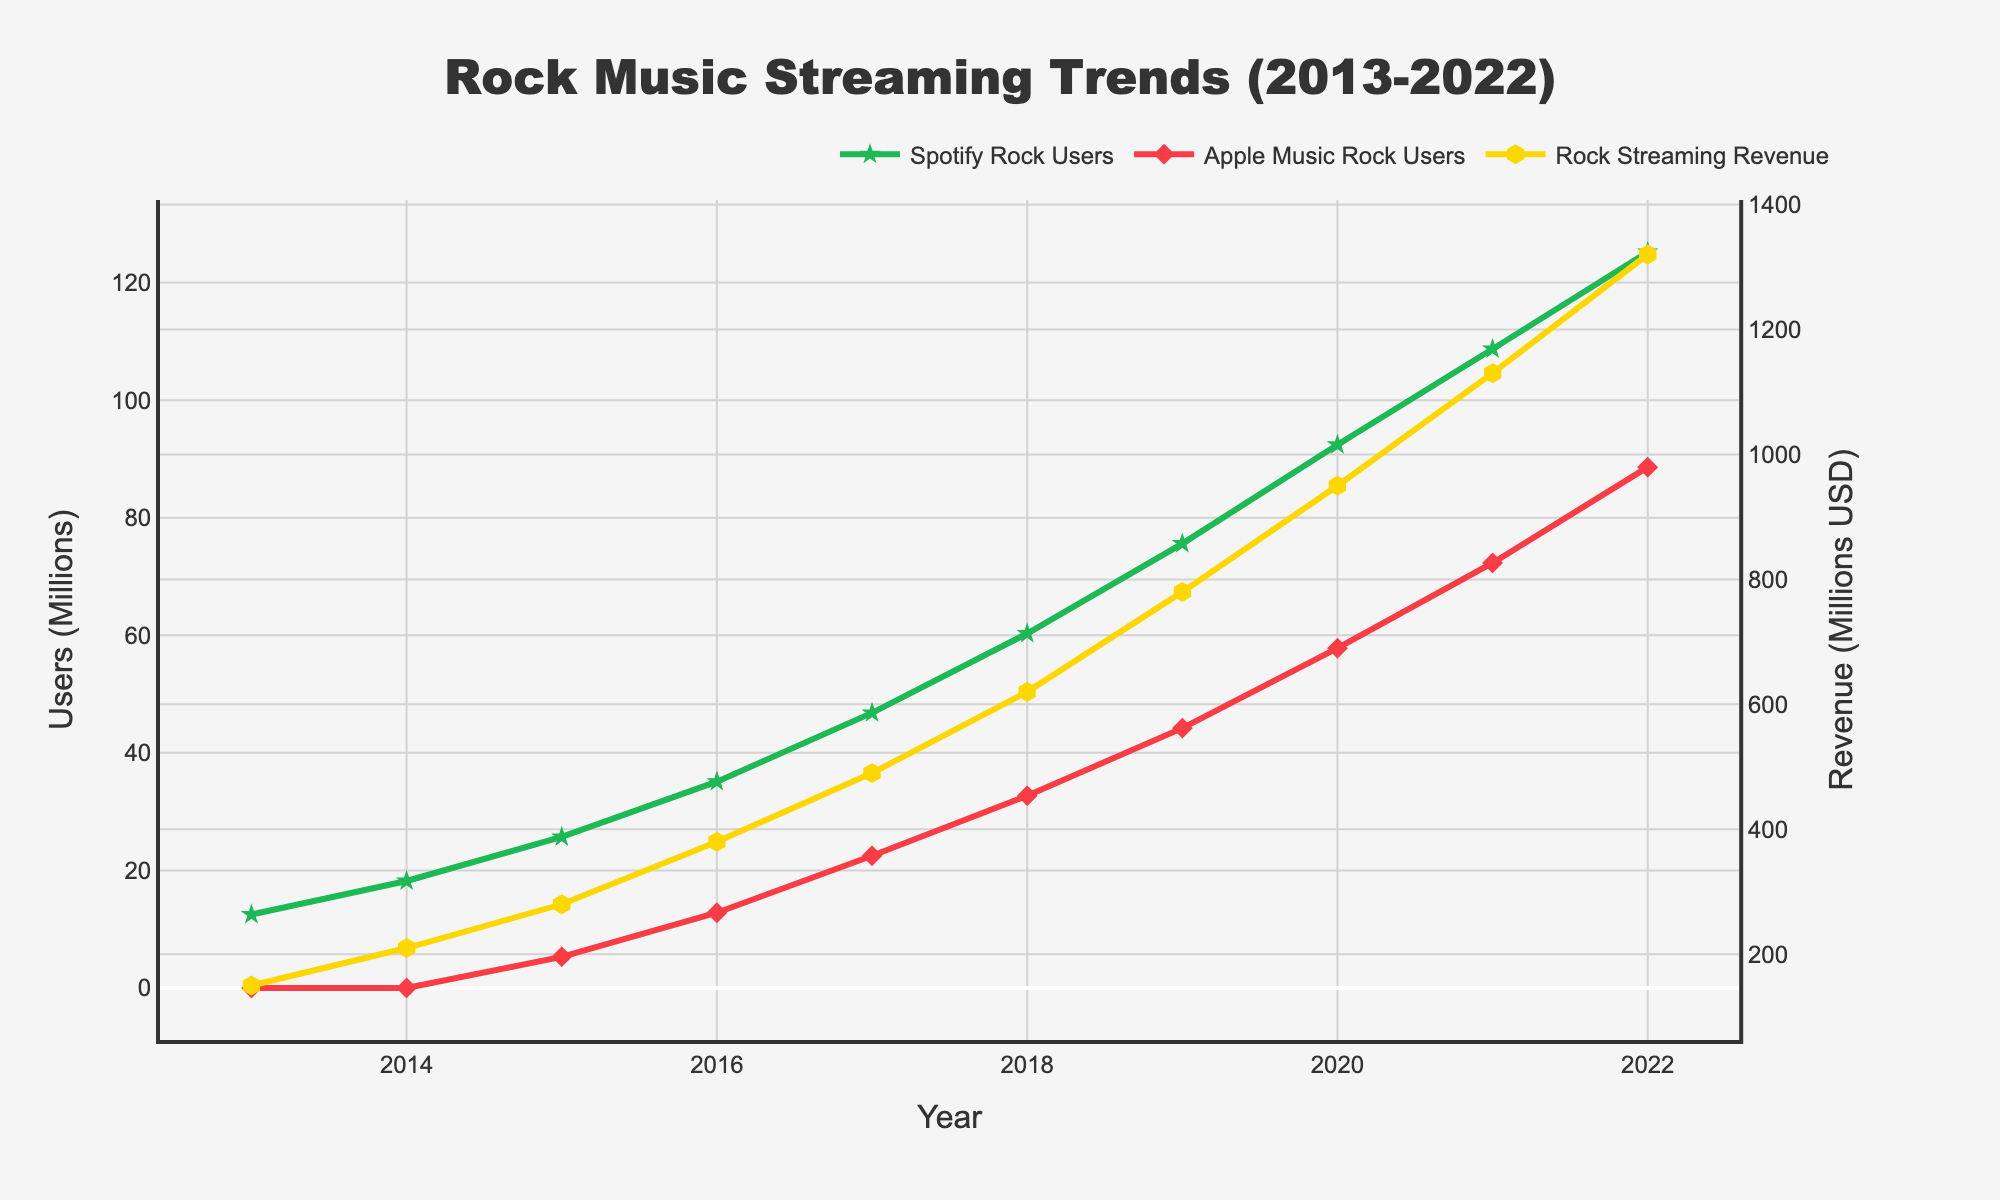Which year had the highest number of Spotify Rock Users? To find the year with the highest number of Spotify Rock Users, we look at the green line and its markers. The peak value is in 2022.
Answer: 2022 Which platform reached 50 million users first, Spotify or Apple Music? To see which platform reached 50 million users first, compare the green line (Spotify) and the red line (Apple Music). Spotify surpassed 50 million users in 2017, while Apple Music reached it in 2020.
Answer: Spotify How much did the Rock Streaming Revenue increase from 2013 to 2020? Find the difference in Rock Streaming Revenue between 2020 and 2013 by looking at the yellow line. The values are 950 million USD in 2020 and 150 million USD in 2013, resulting in 950 - 150 = 800 million USD.
Answer: 800 million USD Which platform had a larger increase in users from 2019 to 2022? Compare the increase in users for Spotify and Apple Music from 2019 to 2022. For Spotify, it’s 125.2 - 75.6 = 49.6 million users, and for Apple Music, it’s 88.6 - 44.2 = 44.4 million users. Spotify had a larger increase.
Answer: Spotify In which year did Rock Streaming Revenue surpass 1,000 million USD? Look at the yellow line representing Rock Streaming Revenue. It crosses the 1,000 million USD mark in 2021.
Answer: 2021 What is the average yearly increase in Spotify Rock Users from 2013 to 2022? Calculate the total increase in Spotify Rock Users over the years (125.2 - 12.5 = 112.7 million users) and divide by the number of years (2022 - 2013 = 9 years). The average increase is 112.7 / 9 ≈ 12.52 million users per year.
Answer: 12.52 million users per year Which year saw the highest annual growth in Apple Music Rock Users? Examining the red line, the steepest increase occurs between 2015 (5.3 million users) and 2016 (12.8 million users), an increase of 12.8 - 5.3 = 7.5 million users.
Answer: 2016 How did the total number of users (Spotify and Apple Music combined) change from 2015 to 2016? Sum the users for each platform in 2015 and 2016 and find the difference: (35.1 + 12.8) - (25.7 + 5.3) = (47.9) - (31) = 16.9 million users.
Answer: 16.9 million users Which platform had more users in 2018, and by how much? Compare the number of users on both platforms in 2018. Spotify had 60.3 million users, and Apple Music had 32.7 million users. The difference is 60.3 - 32.7 = 27.6 million users, with Spotify having more users.
Answer: Spotify, 27.6 million What was the percentage growth in Rock Streaming Revenue from 2017 to 2018? Calculate the percentage growth from 2017 to 2018 using the formula: (Revenue in 2018 - Revenue in 2017) / Revenue in 2017 * 100. This gives (620 - 490) / 490 * 100 ≈ 26.53%.
Answer: 26.53% 